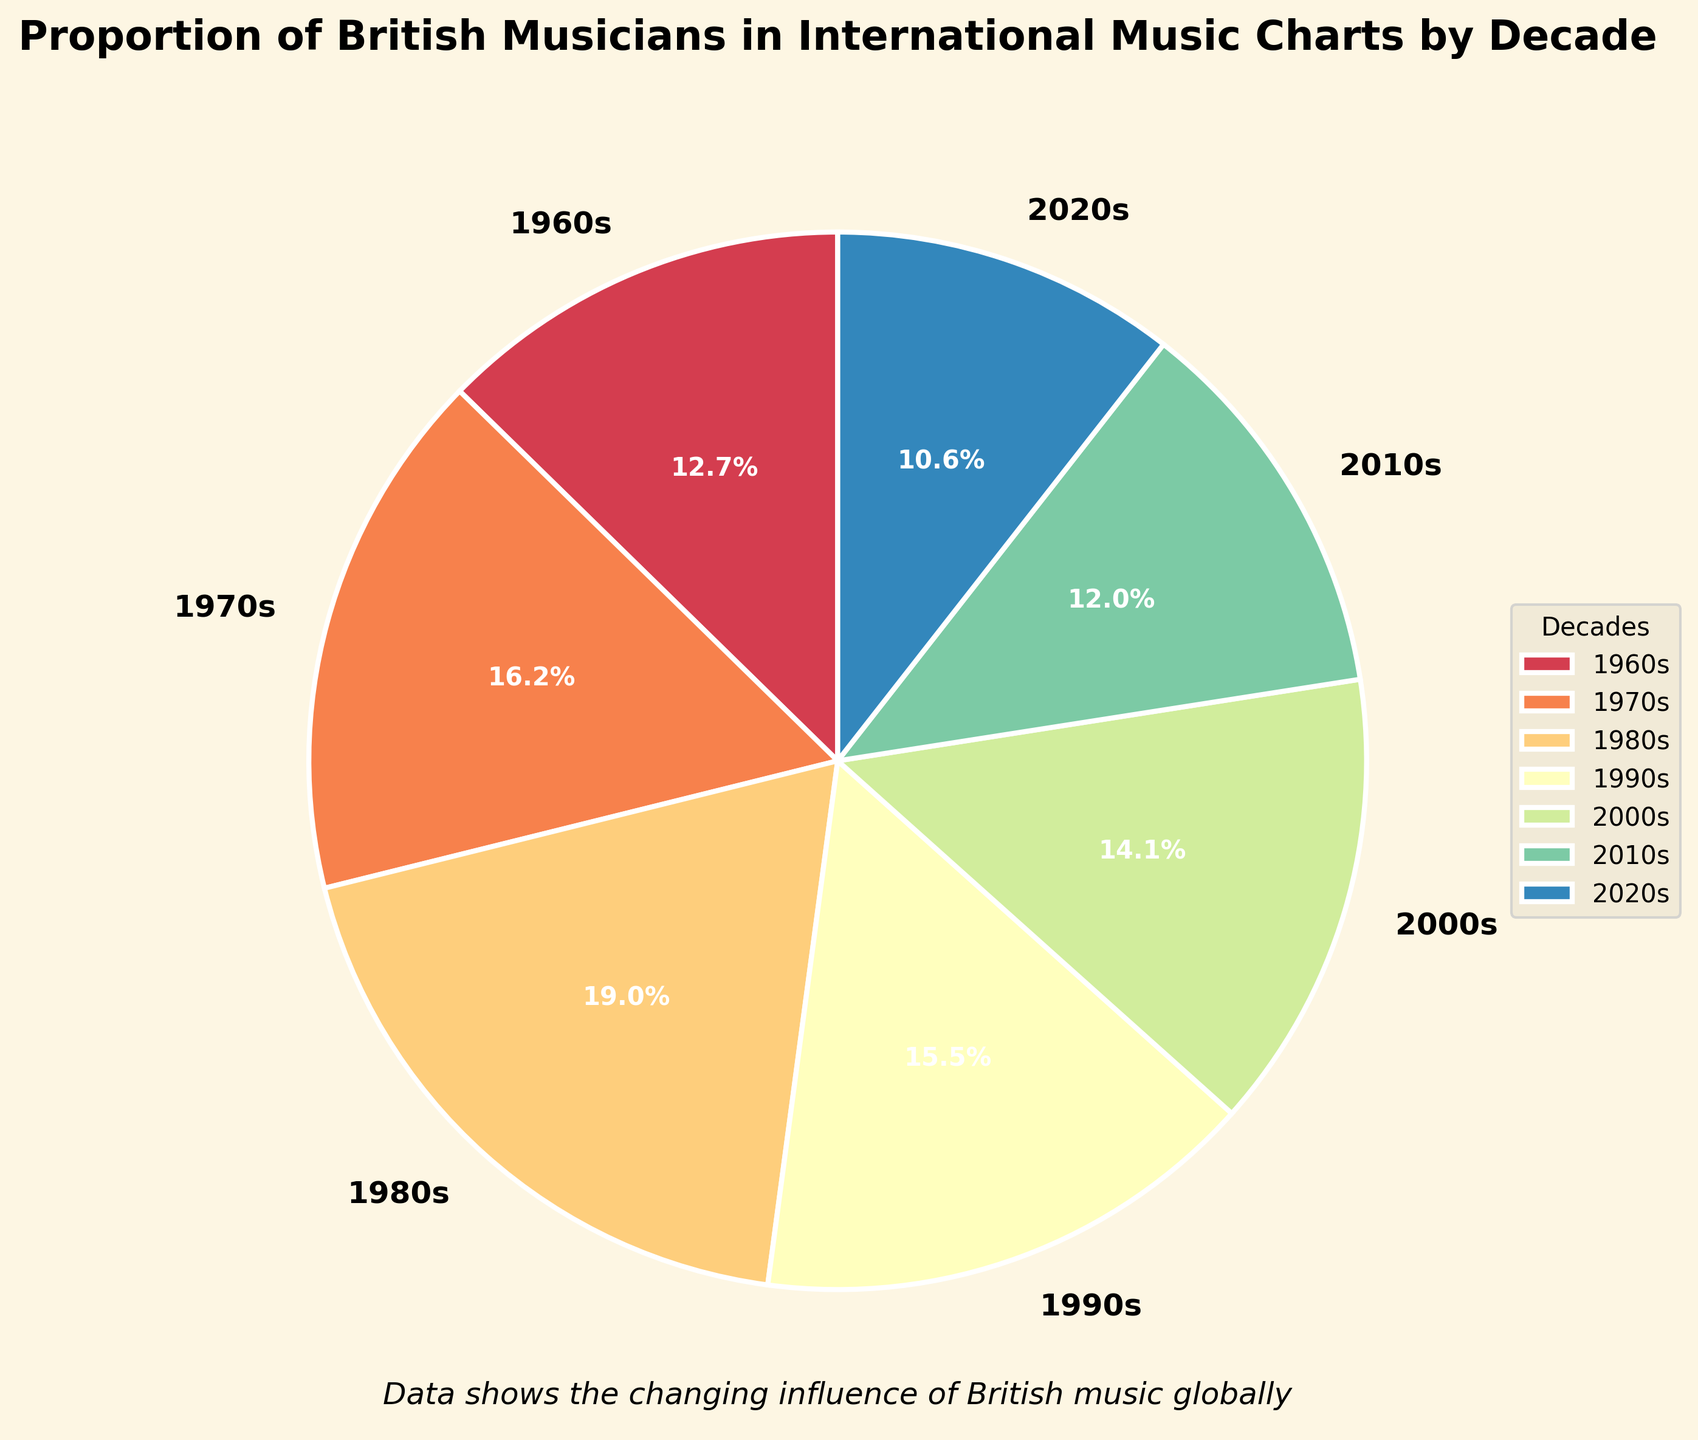1. What decade had the highest proportion of British musicians in international music charts? The decade with the highest proportion is the one with the largest section in the pie chart. Look for the largest wedge segment.
Answer: 1980s 2. Which decade had the lowest proportion of British musicians in international music charts? The smallest segment in the pie chart represents the decade with the lowest proportion.
Answer: 2020s 3. How many decades have a proportion of British musicians greater than 20% in international music charts? Identify all the segments where the percentage is above 20%. Count these segments.
Answer: 3 4. By how much did the proportion of British musicians decrease from the 1980s to the 2010s? Subtract the 2010s proportion from the 1980s proportion: 0.27 - 0.17 = 0.10, then convert to percentage.
Answer: 10% 5. Compare the proportions of British musicians in the 1960s and the 2000s. Which decade had a higher proportion? Determine which segment is larger between the two decades' wedges.
Answer: 1970s 6. By what percentage did the proportion of British musicians change from the 1990s to the 2010s? Calculate the difference: 0.22 - 0.17 = 0.05, then convert to a percentage change: (0.05 / 0.22) * 100 ≈ 22.7%.
Answer: 22.7% 7. What is the combined proportion of British musicians in the 1970s and 1980s? Add the proportions of the 1970s and 1980s: 0.23 + 0.27 = 0.50.
Answer: 50% 8. How does the appearance (color intensity) of the 1960s segment compare to the 2010s segment? Observe the color shades in the pie chart, noting if one is darker or lighter than the other.
Answer: The 1960s segment is darker 9. What is the difference in the proportion of British musicians between the 2000s and the 2020s? Subtract the 2020s proportion from the 2000s: 0.20 - 0.15 = 0.05, then convert to percentage.
Answer: 5% 10. How do the proportions of British musicians in the 1990s and 2000s compare? Which decade had a larger proportion? Compare the size of the two segments for the 1990s (0.22) and 2000s (0.20).
Answer: 1990s 